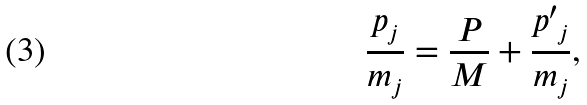Convert formula to latex. <formula><loc_0><loc_0><loc_500><loc_500>\frac { { p _ { j } } } { m _ { j } } = \frac { P } { M } + \frac { { p ^ { \prime } } _ { j } } { m _ { j } } ,</formula> 